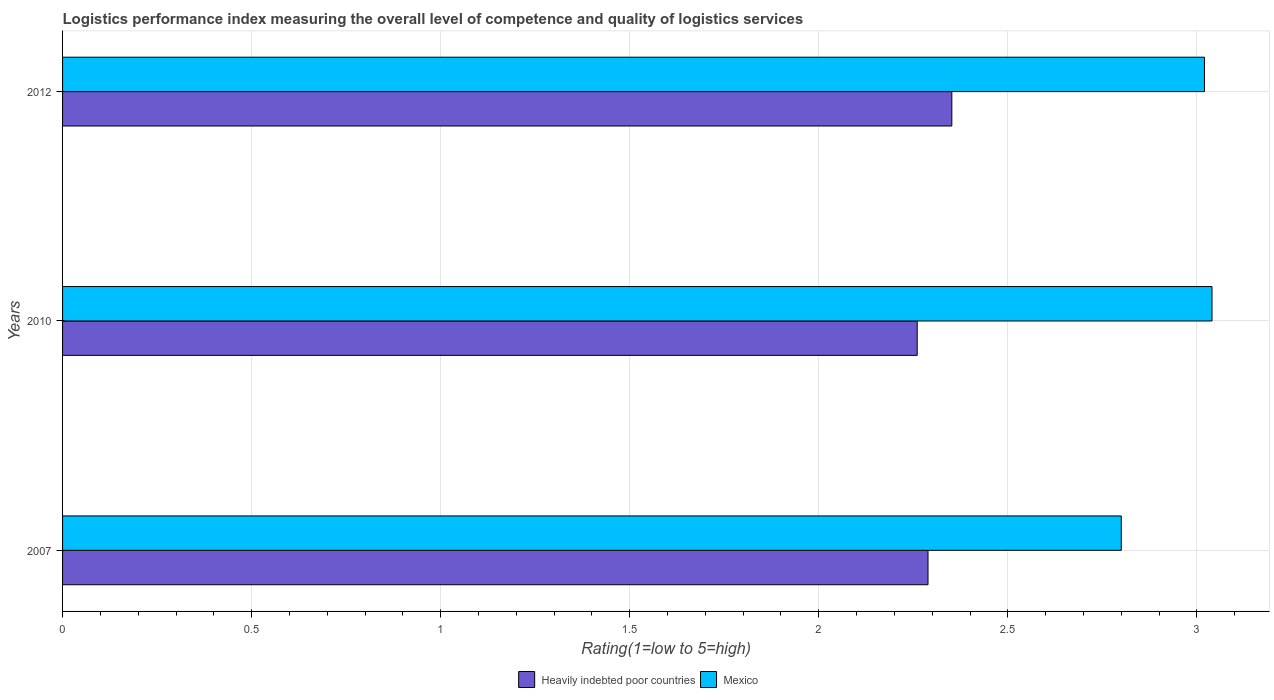How many groups of bars are there?
Make the answer very short. 3. How many bars are there on the 1st tick from the bottom?
Your answer should be very brief. 2. What is the Logistic performance index in Mexico in 2010?
Keep it short and to the point. 3.04. Across all years, what is the maximum Logistic performance index in Heavily indebted poor countries?
Provide a succinct answer. 2.35. Across all years, what is the minimum Logistic performance index in Mexico?
Provide a short and direct response. 2.8. In which year was the Logistic performance index in Mexico maximum?
Your answer should be compact. 2010. What is the total Logistic performance index in Mexico in the graph?
Ensure brevity in your answer.  8.86. What is the difference between the Logistic performance index in Heavily indebted poor countries in 2010 and that in 2012?
Ensure brevity in your answer.  -0.09. What is the difference between the Logistic performance index in Mexico in 2010 and the Logistic performance index in Heavily indebted poor countries in 2007?
Make the answer very short. 0.75. What is the average Logistic performance index in Mexico per year?
Offer a terse response. 2.95. In the year 2007, what is the difference between the Logistic performance index in Mexico and Logistic performance index in Heavily indebted poor countries?
Give a very brief answer. 0.51. What is the ratio of the Logistic performance index in Heavily indebted poor countries in 2010 to that in 2012?
Provide a succinct answer. 0.96. Is the Logistic performance index in Mexico in 2007 less than that in 2010?
Offer a very short reply. Yes. Is the difference between the Logistic performance index in Mexico in 2007 and 2012 greater than the difference between the Logistic performance index in Heavily indebted poor countries in 2007 and 2012?
Keep it short and to the point. No. What is the difference between the highest and the second highest Logistic performance index in Heavily indebted poor countries?
Offer a very short reply. 0.06. What is the difference between the highest and the lowest Logistic performance index in Mexico?
Provide a short and direct response. 0.24. In how many years, is the Logistic performance index in Mexico greater than the average Logistic performance index in Mexico taken over all years?
Offer a terse response. 2. Is the sum of the Logistic performance index in Heavily indebted poor countries in 2007 and 2012 greater than the maximum Logistic performance index in Mexico across all years?
Provide a short and direct response. Yes. How many bars are there?
Keep it short and to the point. 6. Are all the bars in the graph horizontal?
Ensure brevity in your answer.  Yes. How many years are there in the graph?
Give a very brief answer. 3. What is the difference between two consecutive major ticks on the X-axis?
Provide a short and direct response. 0.5. Are the values on the major ticks of X-axis written in scientific E-notation?
Keep it short and to the point. No. Does the graph contain any zero values?
Give a very brief answer. No. How many legend labels are there?
Provide a succinct answer. 2. What is the title of the graph?
Provide a succinct answer. Logistics performance index measuring the overall level of competence and quality of logistics services. Does "Slovenia" appear as one of the legend labels in the graph?
Your answer should be very brief. No. What is the label or title of the X-axis?
Your answer should be compact. Rating(1=low to 5=high). What is the label or title of the Y-axis?
Provide a short and direct response. Years. What is the Rating(1=low to 5=high) in Heavily indebted poor countries in 2007?
Give a very brief answer. 2.29. What is the Rating(1=low to 5=high) in Mexico in 2007?
Your answer should be compact. 2.8. What is the Rating(1=low to 5=high) in Heavily indebted poor countries in 2010?
Offer a very short reply. 2.26. What is the Rating(1=low to 5=high) in Mexico in 2010?
Ensure brevity in your answer.  3.04. What is the Rating(1=low to 5=high) in Heavily indebted poor countries in 2012?
Your response must be concise. 2.35. What is the Rating(1=low to 5=high) in Mexico in 2012?
Ensure brevity in your answer.  3.02. Across all years, what is the maximum Rating(1=low to 5=high) of Heavily indebted poor countries?
Your response must be concise. 2.35. Across all years, what is the maximum Rating(1=low to 5=high) in Mexico?
Provide a succinct answer. 3.04. Across all years, what is the minimum Rating(1=low to 5=high) in Heavily indebted poor countries?
Your response must be concise. 2.26. What is the total Rating(1=low to 5=high) in Heavily indebted poor countries in the graph?
Give a very brief answer. 6.9. What is the total Rating(1=low to 5=high) of Mexico in the graph?
Your response must be concise. 8.86. What is the difference between the Rating(1=low to 5=high) in Heavily indebted poor countries in 2007 and that in 2010?
Provide a short and direct response. 0.03. What is the difference between the Rating(1=low to 5=high) in Mexico in 2007 and that in 2010?
Offer a very short reply. -0.24. What is the difference between the Rating(1=low to 5=high) in Heavily indebted poor countries in 2007 and that in 2012?
Make the answer very short. -0.06. What is the difference between the Rating(1=low to 5=high) in Mexico in 2007 and that in 2012?
Make the answer very short. -0.22. What is the difference between the Rating(1=low to 5=high) in Heavily indebted poor countries in 2010 and that in 2012?
Make the answer very short. -0.09. What is the difference between the Rating(1=low to 5=high) in Heavily indebted poor countries in 2007 and the Rating(1=low to 5=high) in Mexico in 2010?
Offer a very short reply. -0.75. What is the difference between the Rating(1=low to 5=high) in Heavily indebted poor countries in 2007 and the Rating(1=low to 5=high) in Mexico in 2012?
Provide a short and direct response. -0.73. What is the difference between the Rating(1=low to 5=high) of Heavily indebted poor countries in 2010 and the Rating(1=low to 5=high) of Mexico in 2012?
Ensure brevity in your answer.  -0.76. What is the average Rating(1=low to 5=high) in Heavily indebted poor countries per year?
Offer a terse response. 2.3. What is the average Rating(1=low to 5=high) of Mexico per year?
Your answer should be very brief. 2.95. In the year 2007, what is the difference between the Rating(1=low to 5=high) of Heavily indebted poor countries and Rating(1=low to 5=high) of Mexico?
Offer a very short reply. -0.51. In the year 2010, what is the difference between the Rating(1=low to 5=high) of Heavily indebted poor countries and Rating(1=low to 5=high) of Mexico?
Your answer should be compact. -0.78. In the year 2012, what is the difference between the Rating(1=low to 5=high) in Heavily indebted poor countries and Rating(1=low to 5=high) in Mexico?
Make the answer very short. -0.67. What is the ratio of the Rating(1=low to 5=high) of Heavily indebted poor countries in 2007 to that in 2010?
Ensure brevity in your answer.  1.01. What is the ratio of the Rating(1=low to 5=high) in Mexico in 2007 to that in 2010?
Provide a short and direct response. 0.92. What is the ratio of the Rating(1=low to 5=high) in Heavily indebted poor countries in 2007 to that in 2012?
Make the answer very short. 0.97. What is the ratio of the Rating(1=low to 5=high) of Mexico in 2007 to that in 2012?
Your response must be concise. 0.93. What is the ratio of the Rating(1=low to 5=high) of Heavily indebted poor countries in 2010 to that in 2012?
Your answer should be compact. 0.96. What is the ratio of the Rating(1=low to 5=high) of Mexico in 2010 to that in 2012?
Offer a very short reply. 1.01. What is the difference between the highest and the second highest Rating(1=low to 5=high) in Heavily indebted poor countries?
Ensure brevity in your answer.  0.06. What is the difference between the highest and the second highest Rating(1=low to 5=high) of Mexico?
Offer a terse response. 0.02. What is the difference between the highest and the lowest Rating(1=low to 5=high) in Heavily indebted poor countries?
Your answer should be compact. 0.09. What is the difference between the highest and the lowest Rating(1=low to 5=high) of Mexico?
Offer a very short reply. 0.24. 